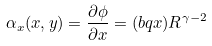<formula> <loc_0><loc_0><loc_500><loc_500>\alpha _ { x } ( x , y ) = \frac { \partial \phi } { \partial x } = ( b q x ) R ^ { \gamma - 2 }</formula> 